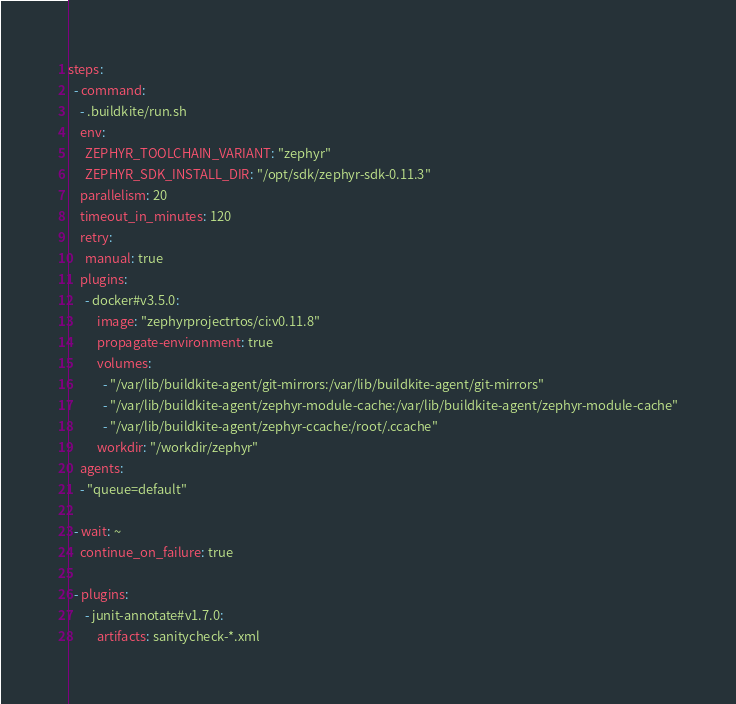Convert code to text. <code><loc_0><loc_0><loc_500><loc_500><_YAML_>steps:
  - command:
    - .buildkite/run.sh
    env:
      ZEPHYR_TOOLCHAIN_VARIANT: "zephyr"
      ZEPHYR_SDK_INSTALL_DIR: "/opt/sdk/zephyr-sdk-0.11.3"
    parallelism: 20
    timeout_in_minutes: 120
    retry:
      manual: true
    plugins:
      - docker#v3.5.0:
          image: "zephyrprojectrtos/ci:v0.11.8"
          propagate-environment: true
          volumes:
            - "/var/lib/buildkite-agent/git-mirrors:/var/lib/buildkite-agent/git-mirrors"
            - "/var/lib/buildkite-agent/zephyr-module-cache:/var/lib/buildkite-agent/zephyr-module-cache"
            - "/var/lib/buildkite-agent/zephyr-ccache:/root/.ccache"
          workdir: "/workdir/zephyr"
    agents:
    - "queue=default"

  - wait: ~
    continue_on_failure: true

  - plugins:
      - junit-annotate#v1.7.0:
          artifacts: sanitycheck-*.xml
</code> 